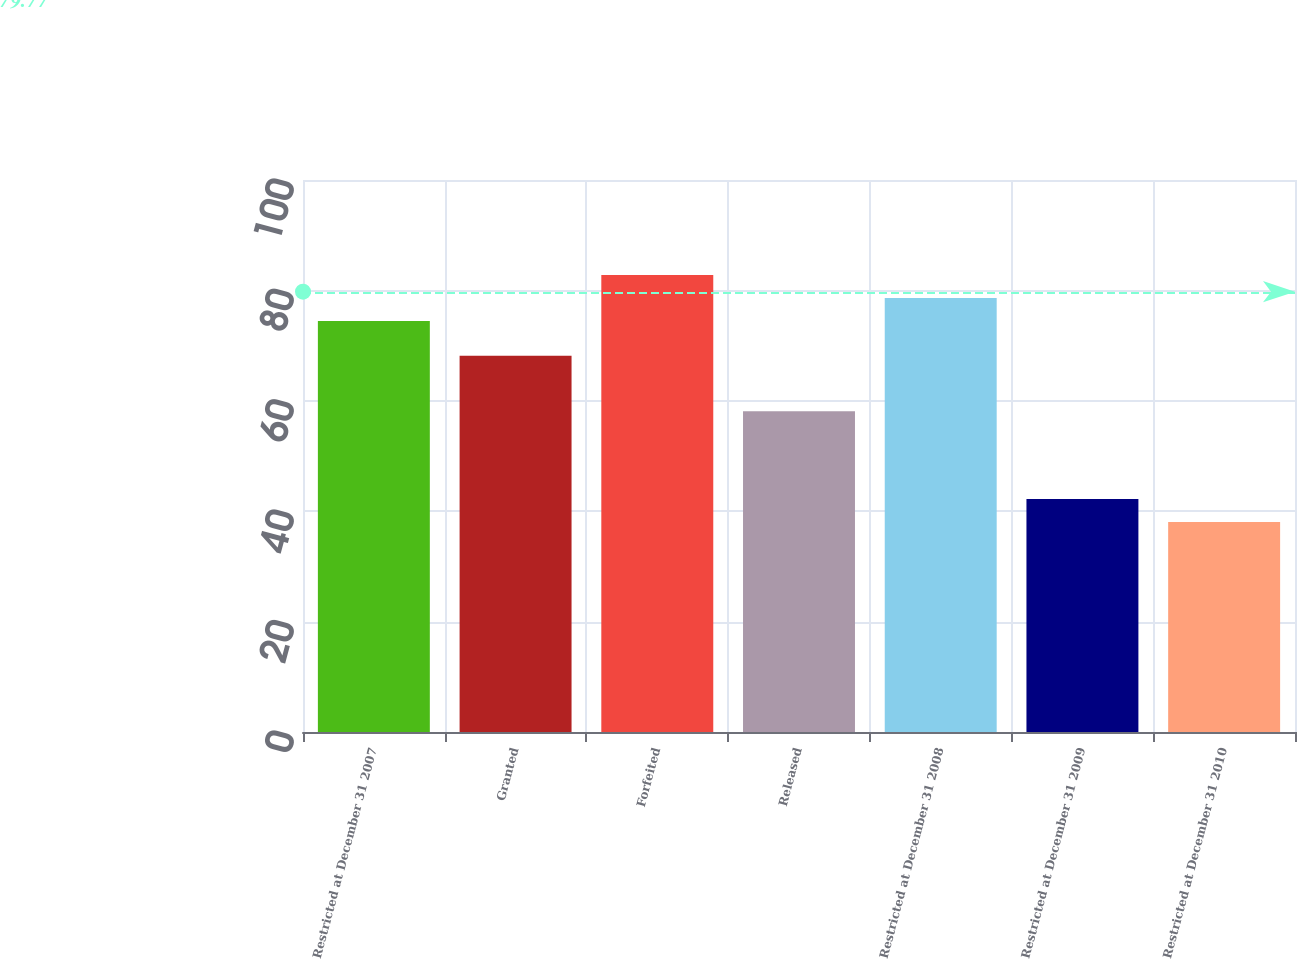Convert chart to OTSL. <chart><loc_0><loc_0><loc_500><loc_500><bar_chart><fcel>Restricted at December 31 2007<fcel>Granted<fcel>Forfeited<fcel>Released<fcel>Restricted at December 31 2008<fcel>Restricted at December 31 2009<fcel>Restricted at December 31 2010<nl><fcel>74.47<fcel>68.17<fcel>82.79<fcel>58.12<fcel>78.63<fcel>42.19<fcel>38.03<nl></chart> 